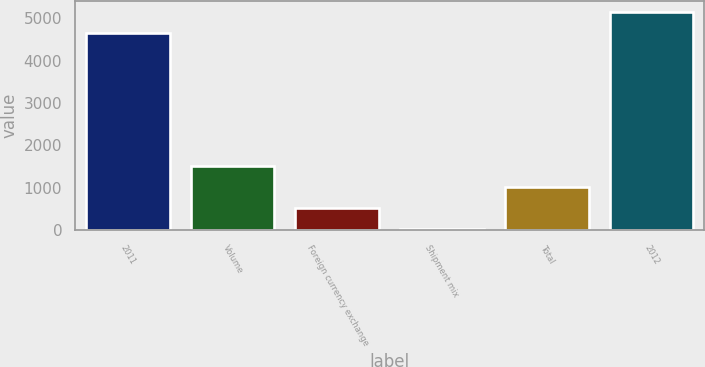<chart> <loc_0><loc_0><loc_500><loc_500><bar_chart><fcel>2011<fcel>Volume<fcel>Foreign currency exchange<fcel>Shipment mix<fcel>Total<fcel>2012<nl><fcel>4662<fcel>1506.7<fcel>524.9<fcel>34<fcel>1015.8<fcel>5152.9<nl></chart> 